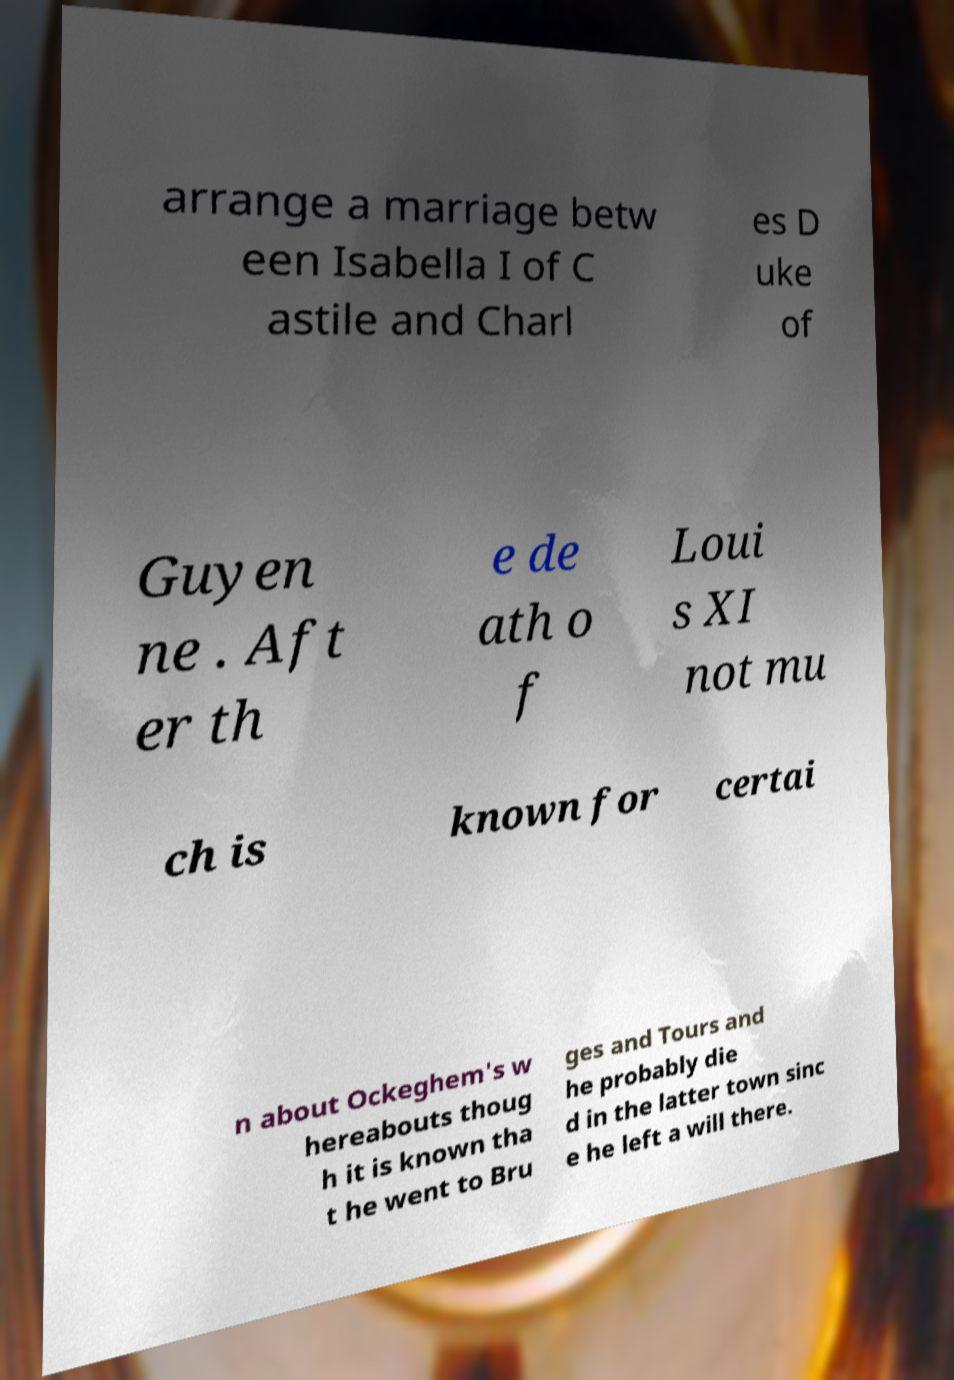There's text embedded in this image that I need extracted. Can you transcribe it verbatim? arrange a marriage betw een Isabella I of C astile and Charl es D uke of Guyen ne . Aft er th e de ath o f Loui s XI not mu ch is known for certai n about Ockeghem's w hereabouts thoug h it is known tha t he went to Bru ges and Tours and he probably die d in the latter town sinc e he left a will there. 